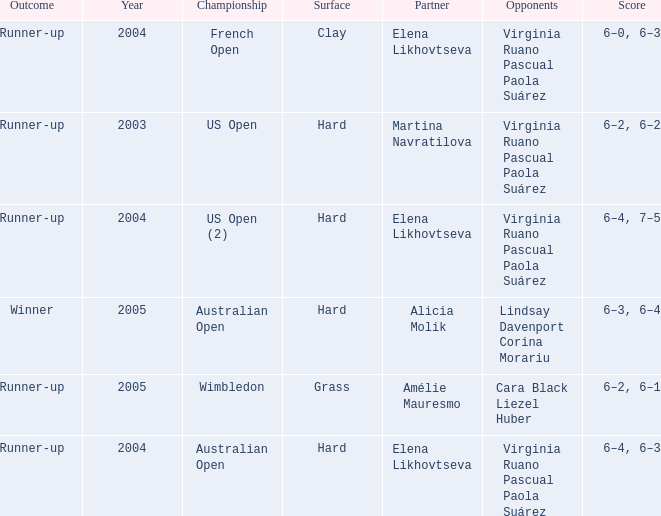When us open (2) is the championship what is the surface? Hard. 